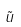<formula> <loc_0><loc_0><loc_500><loc_500>\tilde { u }</formula> 